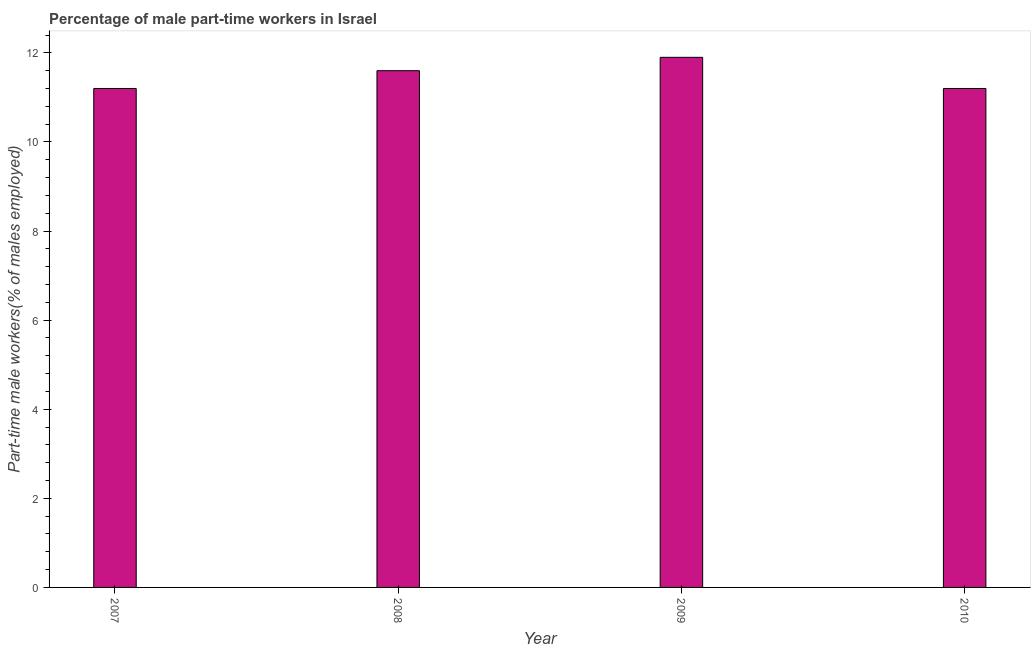Does the graph contain grids?
Keep it short and to the point. No. What is the title of the graph?
Your response must be concise. Percentage of male part-time workers in Israel. What is the label or title of the X-axis?
Your response must be concise. Year. What is the label or title of the Y-axis?
Give a very brief answer. Part-time male workers(% of males employed). What is the percentage of part-time male workers in 2009?
Your response must be concise. 11.9. Across all years, what is the maximum percentage of part-time male workers?
Offer a very short reply. 11.9. Across all years, what is the minimum percentage of part-time male workers?
Provide a short and direct response. 11.2. In which year was the percentage of part-time male workers maximum?
Offer a very short reply. 2009. In which year was the percentage of part-time male workers minimum?
Offer a very short reply. 2007. What is the sum of the percentage of part-time male workers?
Make the answer very short. 45.9. What is the average percentage of part-time male workers per year?
Provide a short and direct response. 11.47. What is the median percentage of part-time male workers?
Make the answer very short. 11.4. In how many years, is the percentage of part-time male workers greater than 6 %?
Provide a short and direct response. 4. What is the difference between the highest and the second highest percentage of part-time male workers?
Provide a succinct answer. 0.3. In how many years, is the percentage of part-time male workers greater than the average percentage of part-time male workers taken over all years?
Keep it short and to the point. 2. How many bars are there?
Make the answer very short. 4. Are all the bars in the graph horizontal?
Your response must be concise. No. How many years are there in the graph?
Your response must be concise. 4. Are the values on the major ticks of Y-axis written in scientific E-notation?
Your response must be concise. No. What is the Part-time male workers(% of males employed) of 2007?
Ensure brevity in your answer.  11.2. What is the Part-time male workers(% of males employed) of 2008?
Keep it short and to the point. 11.6. What is the Part-time male workers(% of males employed) in 2009?
Offer a very short reply. 11.9. What is the Part-time male workers(% of males employed) in 2010?
Offer a terse response. 11.2. What is the difference between the Part-time male workers(% of males employed) in 2007 and 2008?
Your answer should be very brief. -0.4. What is the difference between the Part-time male workers(% of males employed) in 2007 and 2009?
Provide a succinct answer. -0.7. What is the difference between the Part-time male workers(% of males employed) in 2009 and 2010?
Keep it short and to the point. 0.7. What is the ratio of the Part-time male workers(% of males employed) in 2007 to that in 2009?
Give a very brief answer. 0.94. What is the ratio of the Part-time male workers(% of males employed) in 2008 to that in 2009?
Your response must be concise. 0.97. What is the ratio of the Part-time male workers(% of males employed) in 2008 to that in 2010?
Make the answer very short. 1.04. What is the ratio of the Part-time male workers(% of males employed) in 2009 to that in 2010?
Give a very brief answer. 1.06. 